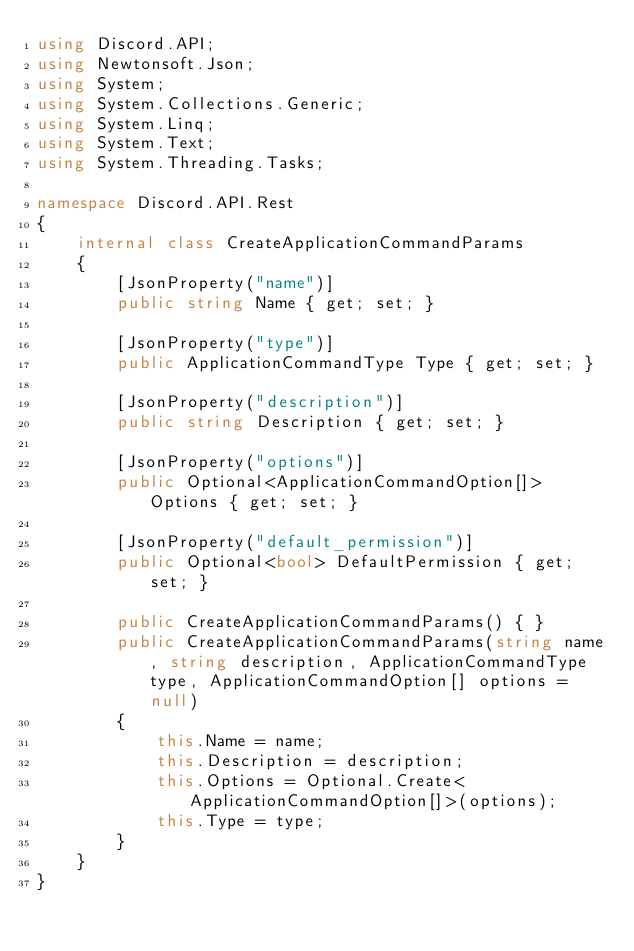Convert code to text. <code><loc_0><loc_0><loc_500><loc_500><_C#_>using Discord.API;
using Newtonsoft.Json;
using System;
using System.Collections.Generic;
using System.Linq;
using System.Text;
using System.Threading.Tasks;

namespace Discord.API.Rest
{
    internal class CreateApplicationCommandParams
    {
        [JsonProperty("name")]
        public string Name { get; set; }

        [JsonProperty("type")]
        public ApplicationCommandType Type { get; set; }

        [JsonProperty("description")]
        public string Description { get; set; }

        [JsonProperty("options")]
        public Optional<ApplicationCommandOption[]> Options { get; set; }

        [JsonProperty("default_permission")]
        public Optional<bool> DefaultPermission { get; set; }

        public CreateApplicationCommandParams() { }
        public CreateApplicationCommandParams(string name, string description, ApplicationCommandType type, ApplicationCommandOption[] options = null)
        {
            this.Name = name;
            this.Description = description;
            this.Options = Optional.Create<ApplicationCommandOption[]>(options);
            this.Type = type;
        }
    }
}
</code> 